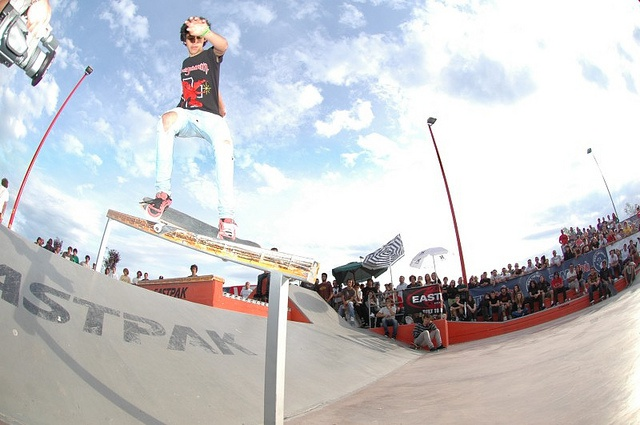Describe the objects in this image and their specific colors. I can see people in tan, black, gray, maroon, and white tones, people in tan, white, gray, lightpink, and lightblue tones, skateboard in tan, darkgray, lightgray, and gray tones, umbrella in tan, darkgray, lightgray, and gray tones, and people in tan, gray, black, maroon, and darkgray tones in this image. 